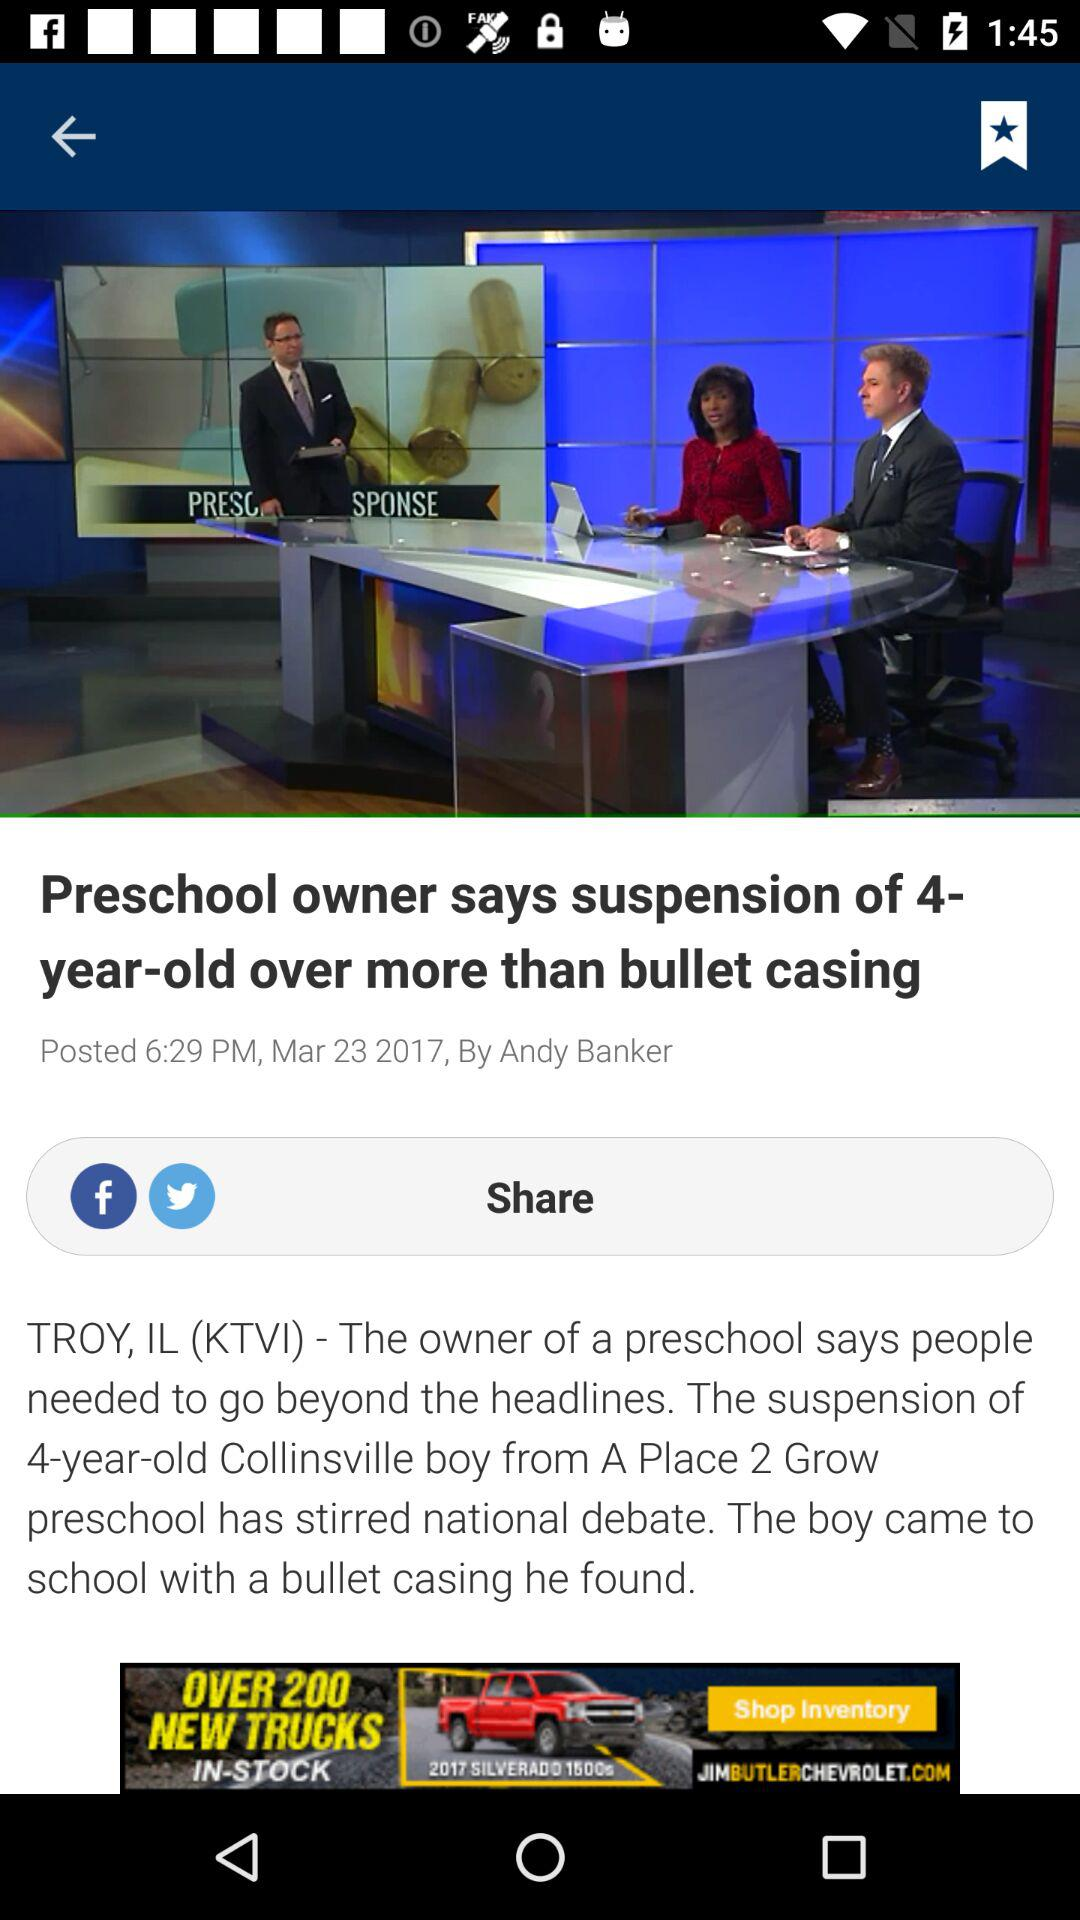What is the time and date of the post? The time and date of the post are 6:29 PM and March 23, 2017, respectively. 